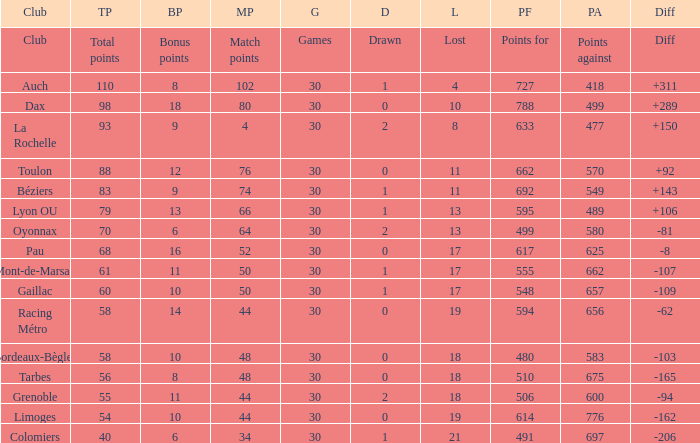What is the diff for a club that has a value of 662 for points for? 92.0. 